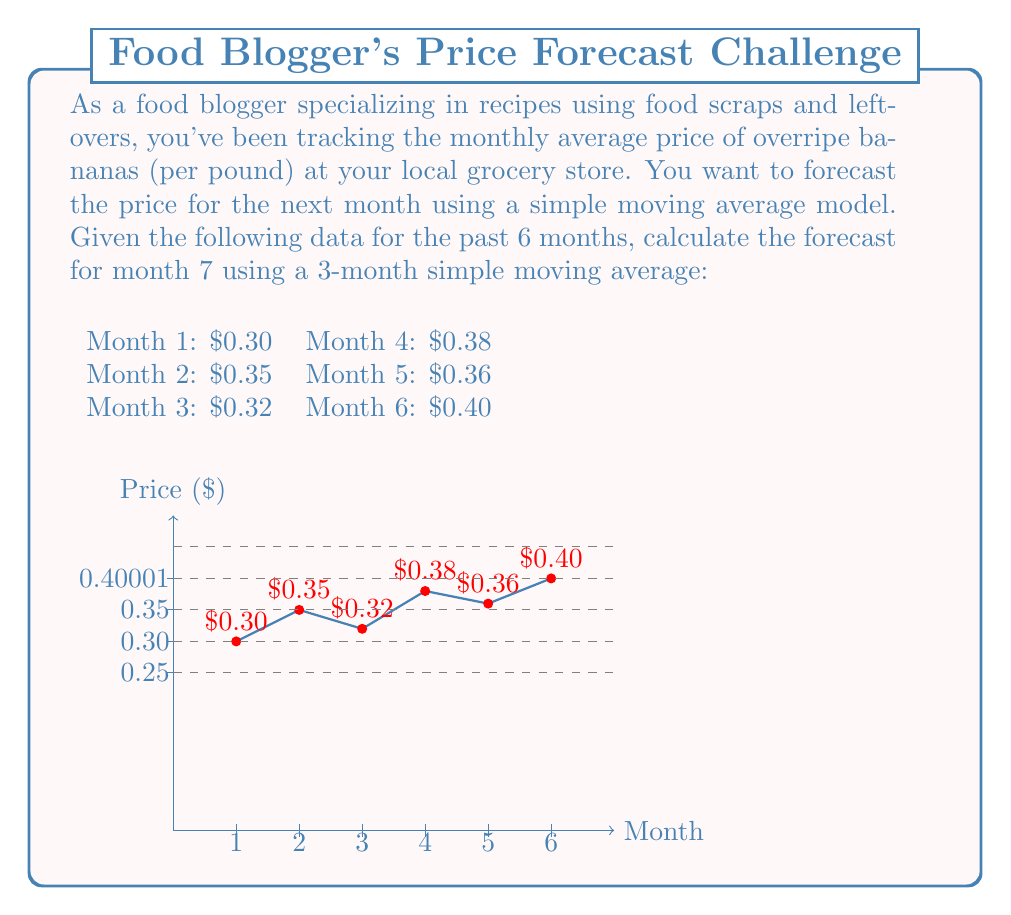Provide a solution to this math problem. To calculate the forecast for month 7 using a 3-month simple moving average, we need to follow these steps:

1. The 3-month simple moving average is calculated by taking the average of the previous 3 months' prices.

2. For month 7, we'll use the prices from months 4, 5, and 6.

3. Let's denote the price for month i as $P_i$. The formula for the 3-month simple moving average forecast ($F_7$) is:

   $$F_7 = \frac{P_4 + P_5 + P_6}{3}$$

4. Substituting the values:
   $$F_7 = \frac{0.38 + 0.36 + 0.40}{3}$$

5. Calculating:
   $$F_7 = \frac{1.14}{3} = 0.38$$

Therefore, the forecast price for overripe bananas in month 7 is $0.38 per pound.
Answer: $0.38 per pound 